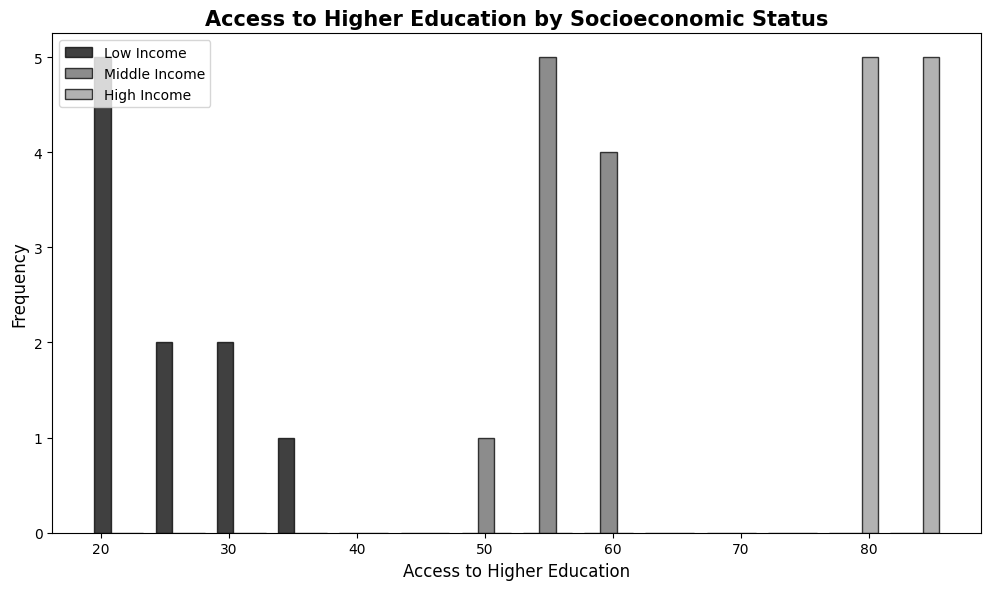How many distinct socioeconomic status groups are represented in the histogram? The x-axis labels indicate three distinct groups: Low Income, Middle Income, and High Income.
Answer: 3 Which socioeconomic group has the highest access to higher education? From the histogram bars, the High Income group's bars are positioned further to the right, indicating higher values.
Answer: High Income Which group has the lowest range of access to higher education? The bars for the Low Income group are packed close together and mostly towards the lower end of the x-axis.
Answer: Low Income What is the approximate median value of access to higher education for the Middle Income group? The Middle Income group's data points are spread between 52 and 62. The middle value is approximately 56 or 57.
Answer: ~56-57 How does the range of access to higher education in the High Income group compare with the Middle Income group? The High Income group's bars range from 77 to 86, while the Middle Income group's bars range from 52 to 62. The High Income group has a wider range.
Answer: Wider Which group's histogram bars are more spread out: Low Income or High Income? Observing the range on the x-axis, the High Income group's bars are more spread out from 77 to 86 compared to Low Income's 19 to 34.
Answer: High Income Compare the average access to higher education between Low Income and Middle Income groups. Average for Low Income: (34+29+22+25+27+30+20+19+23+21)/10 = 25, for Middle Income: (55+58+54+53+57+62+60+56+59+52)/10 = 56.4.
Answer: Middle Income higher What is the overlap in access to higher education between any two groups? Check the histogram overlap: Low Income (19-34), Middle Income (52-62), High Income (77-86). No overlap is visually apparent between any two groups.
Answer: None Are the frequencies of access to higher education visually similar within each socioeconomic group? The histogram bars within each group are of similar height and consistent, indicating relatively similar frequencies within each group.
Answer: Yes 